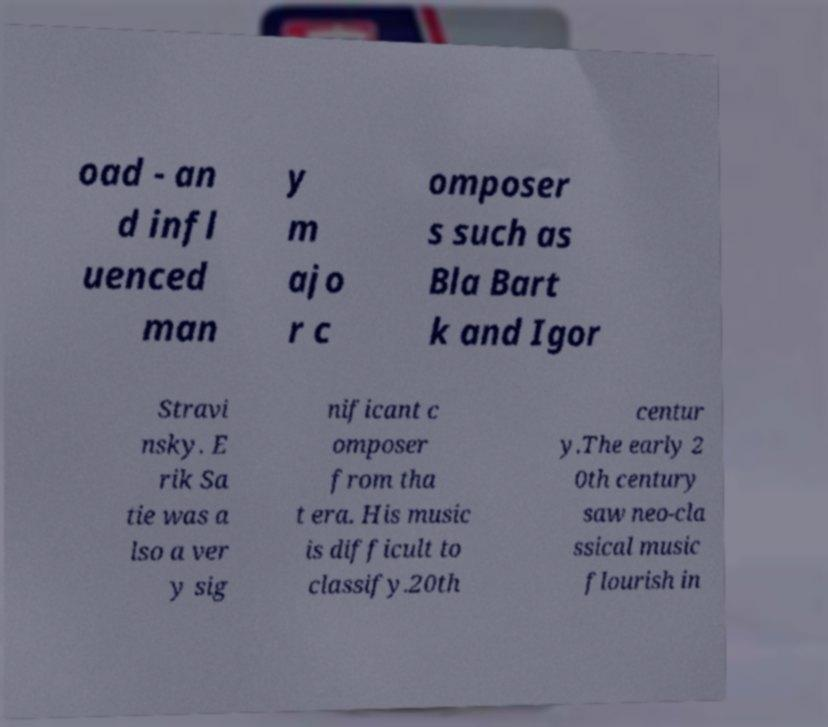There's text embedded in this image that I need extracted. Can you transcribe it verbatim? oad - an d infl uenced man y m ajo r c omposer s such as Bla Bart k and Igor Stravi nsky. E rik Sa tie was a lso a ver y sig nificant c omposer from tha t era. His music is difficult to classify.20th centur y.The early 2 0th century saw neo-cla ssical music flourish in 